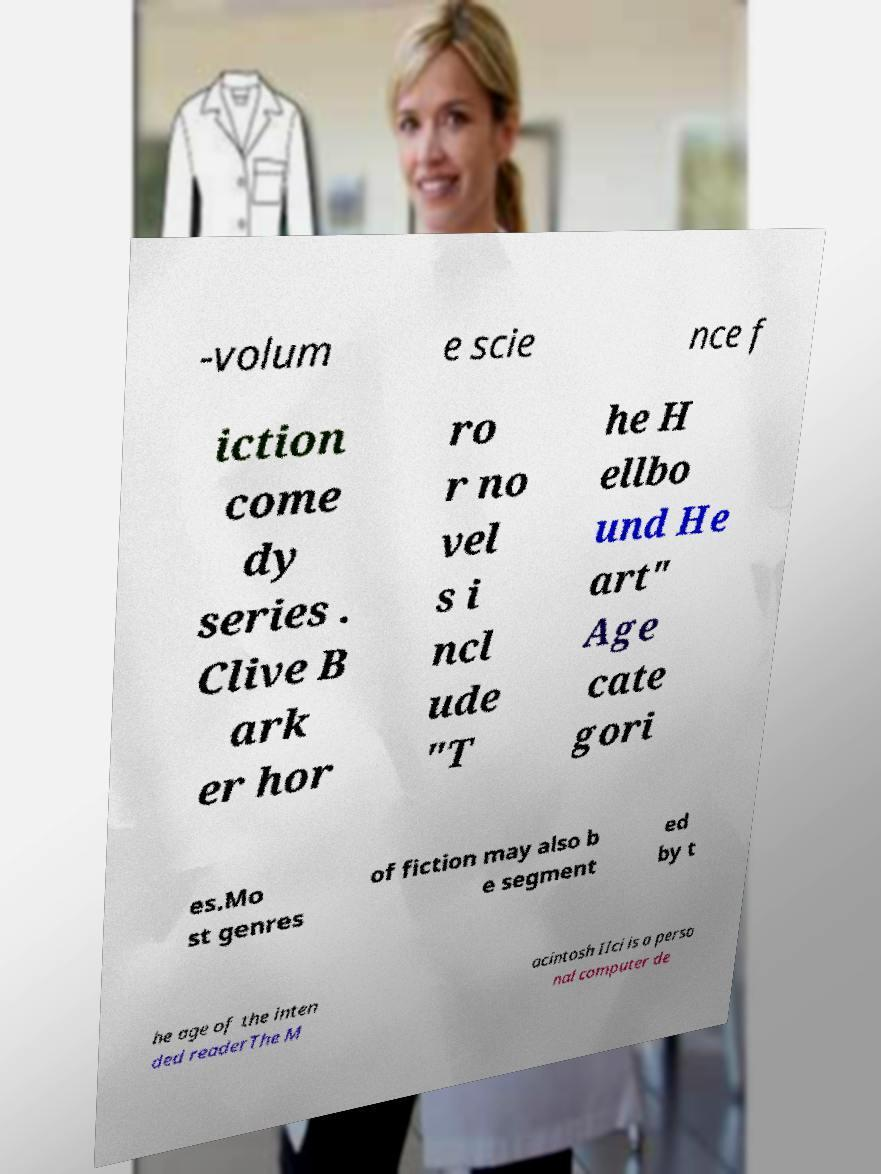Can you read and provide the text displayed in the image?This photo seems to have some interesting text. Can you extract and type it out for me? -volum e scie nce f iction come dy series . Clive B ark er hor ro r no vel s i ncl ude "T he H ellbo und He art" Age cate gori es.Mo st genres of fiction may also b e segment ed by t he age of the inten ded readerThe M acintosh IIci is a perso nal computer de 